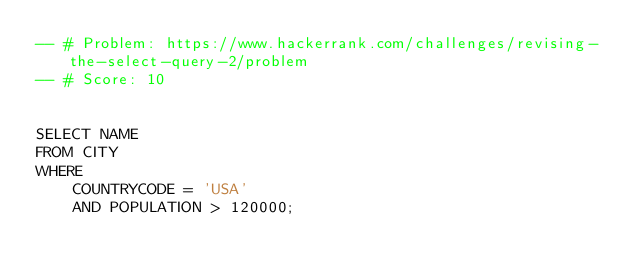<code> <loc_0><loc_0><loc_500><loc_500><_SQL_>-- # Problem: https://www.hackerrank.com/challenges/revising-the-select-query-2/problem
-- # Score: 10


SELECT NAME
FROM CITY
WHERE
    COUNTRYCODE = 'USA'
    AND POPULATION > 120000;
</code> 